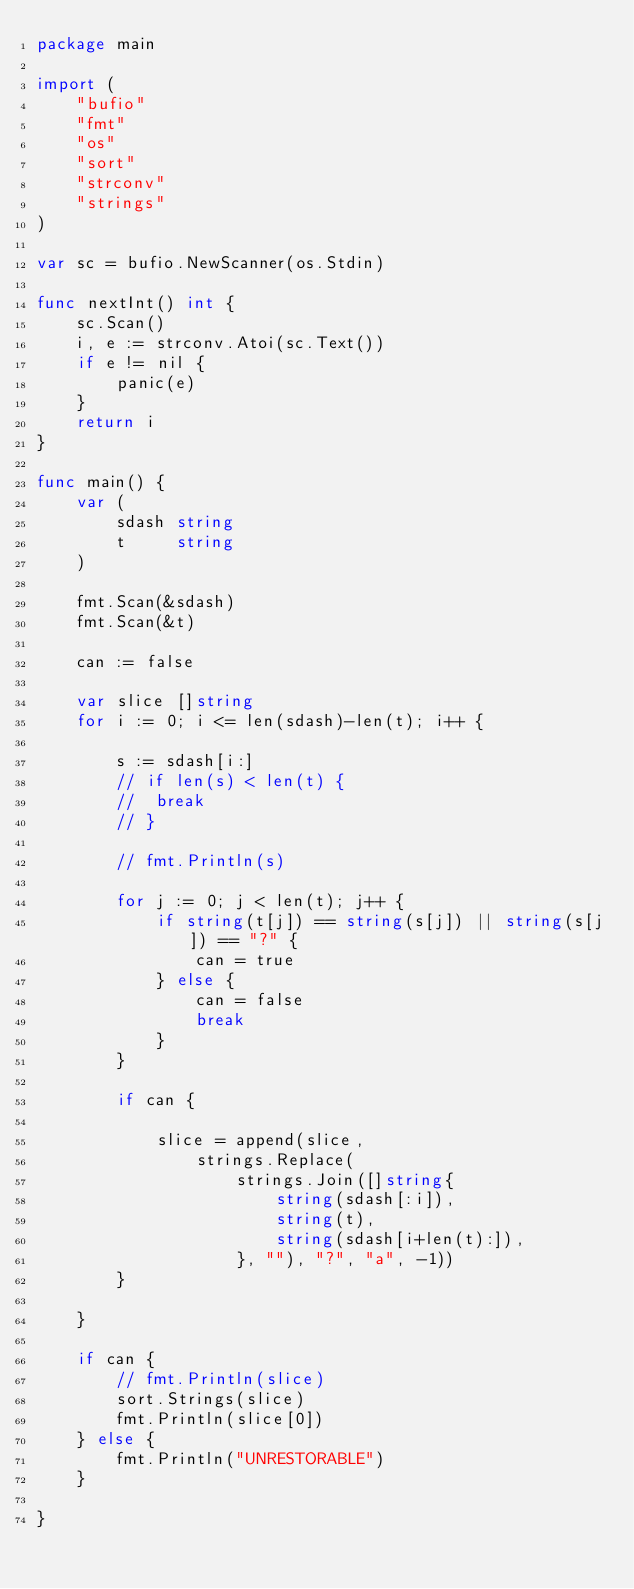Convert code to text. <code><loc_0><loc_0><loc_500><loc_500><_Go_>package main

import (
	"bufio"
	"fmt"
	"os"
	"sort"
	"strconv"
	"strings"
)

var sc = bufio.NewScanner(os.Stdin)

func nextInt() int {
	sc.Scan()
	i, e := strconv.Atoi(sc.Text())
	if e != nil {
		panic(e)
	}
	return i
}

func main() {
	var (
		sdash string
		t     string
	)

	fmt.Scan(&sdash)
	fmt.Scan(&t)

	can := false

	var slice []string
	for i := 0; i <= len(sdash)-len(t); i++ {

		s := sdash[i:]
		// if len(s) < len(t) {
		// 	break
		// }

		// fmt.Println(s)

		for j := 0; j < len(t); j++ {
			if string(t[j]) == string(s[j]) || string(s[j]) == "?" {
				can = true
			} else {
				can = false
				break
			}
		}

		if can {

			slice = append(slice,
				strings.Replace(
					strings.Join([]string{
						string(sdash[:i]),
						string(t),
						string(sdash[i+len(t):]),
					}, ""), "?", "a", -1))
		}

	}

	if can {
		// fmt.Println(slice)
		sort.Strings(slice)
		fmt.Println(slice[0])
	} else {
		fmt.Println("UNRESTORABLE")
	}

}
</code> 